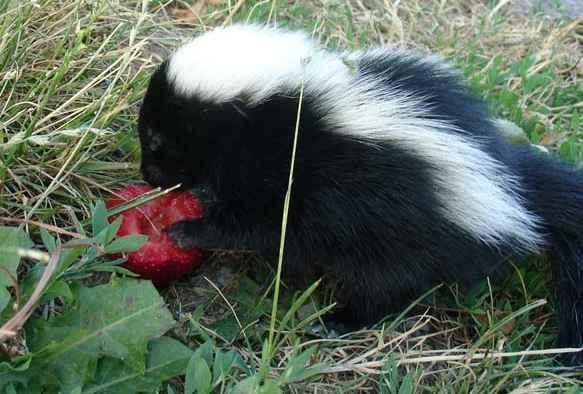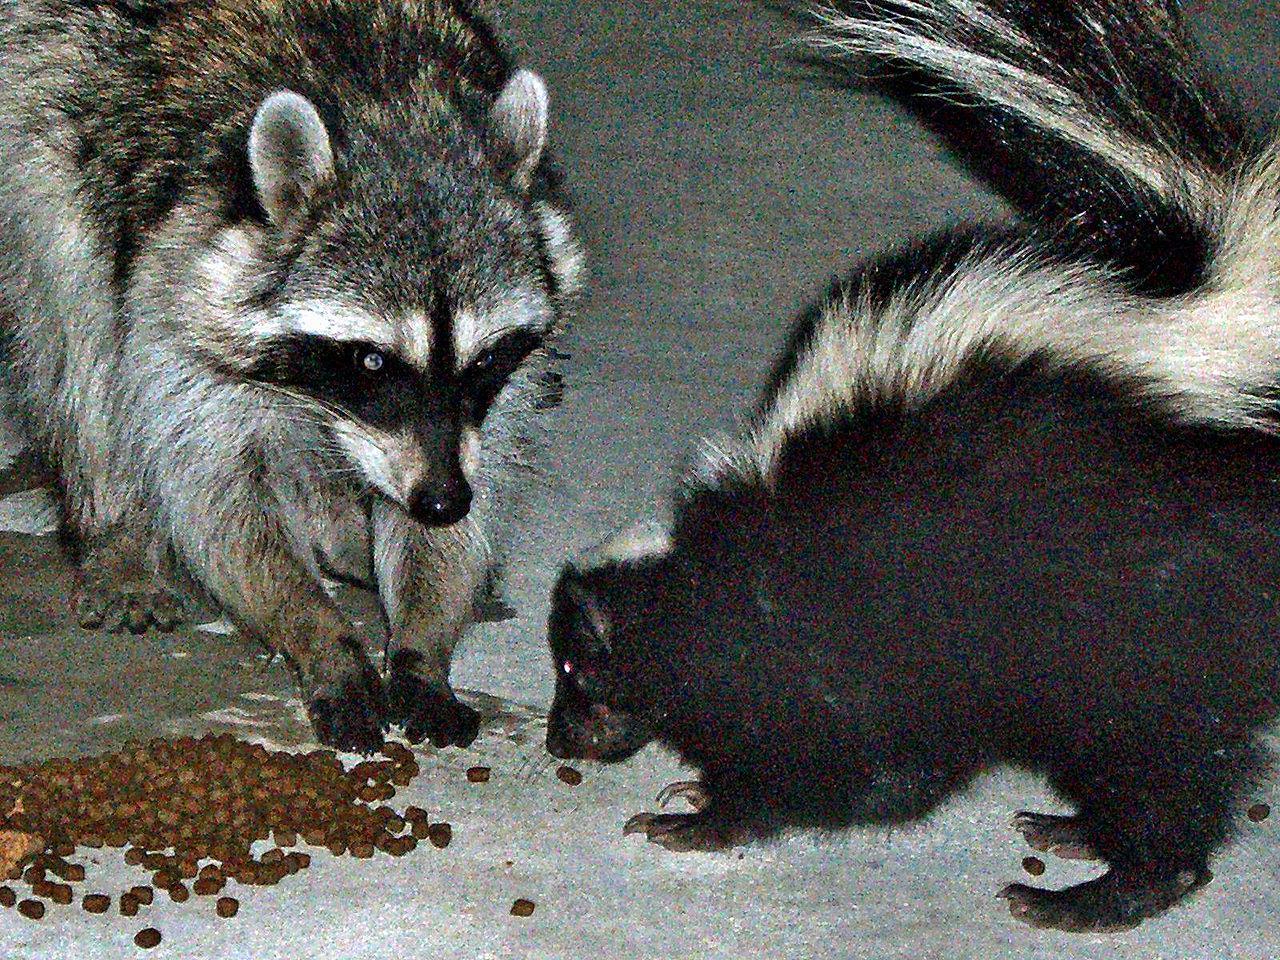The first image is the image on the left, the second image is the image on the right. Evaluate the accuracy of this statement regarding the images: "One of the images has a skunk along with a an animal that is not a skunk.". Is it true? Answer yes or no. Yes. The first image is the image on the left, the second image is the image on the right. Assess this claim about the two images: "In one of the images an animal can be seen eating dog food.". Correct or not? Answer yes or no. Yes. 